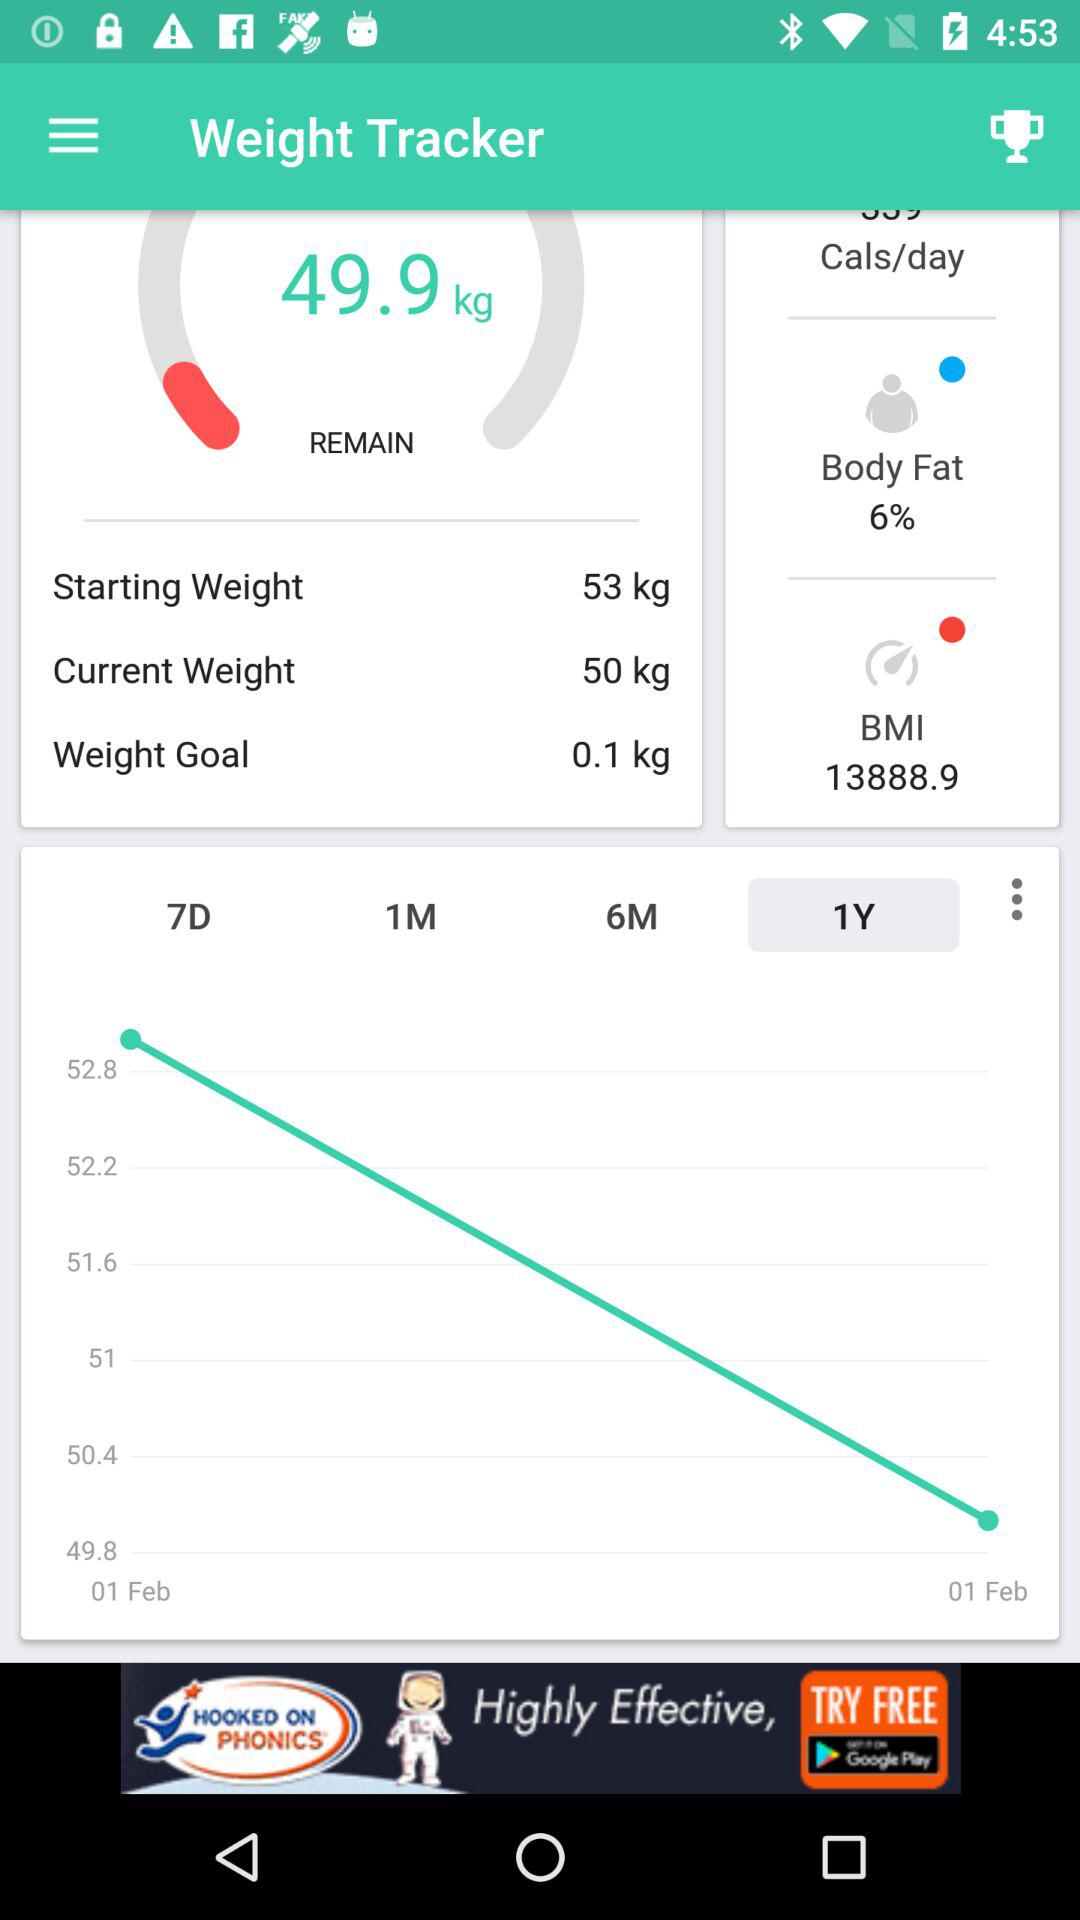What percentage of body fat is given? The given body fat percentage is 6. 